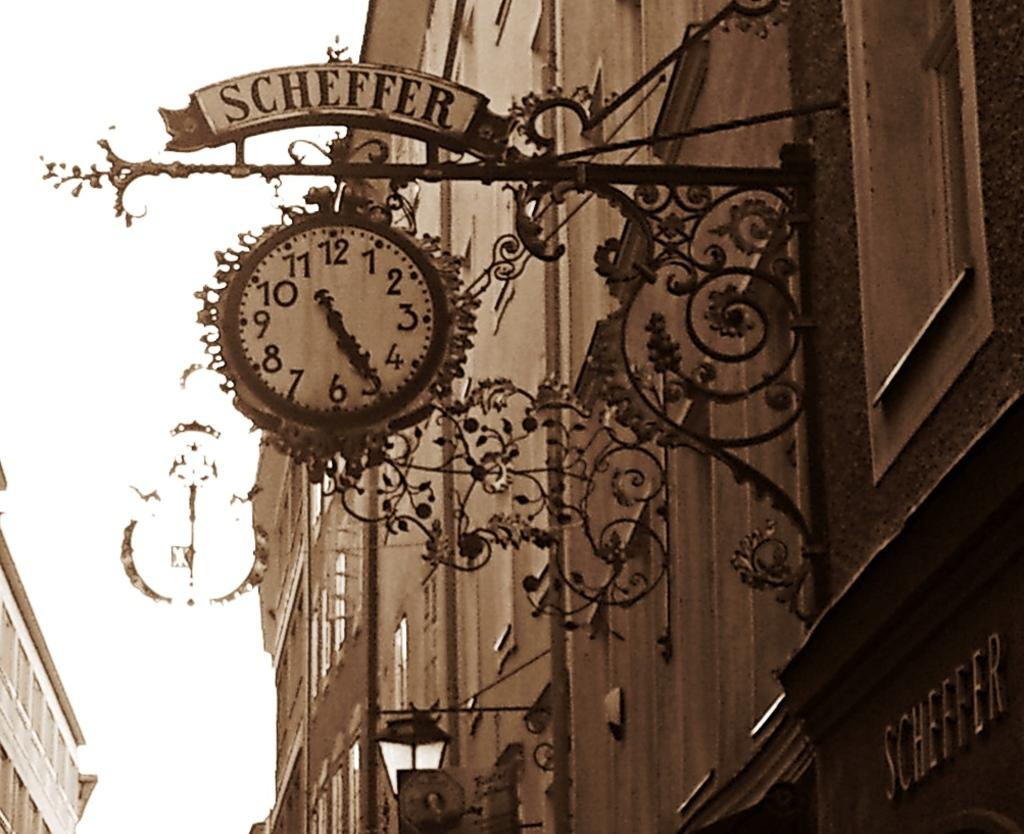Provide a one-sentence caption for the provided image. The clock at Scheffer shows that it is 11:25. 